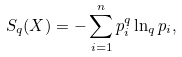Convert formula to latex. <formula><loc_0><loc_0><loc_500><loc_500>S _ { q } ( X ) = - \sum _ { i = 1 } ^ { n } p _ { i } ^ { q } \ln _ { q } p _ { i } ,</formula> 